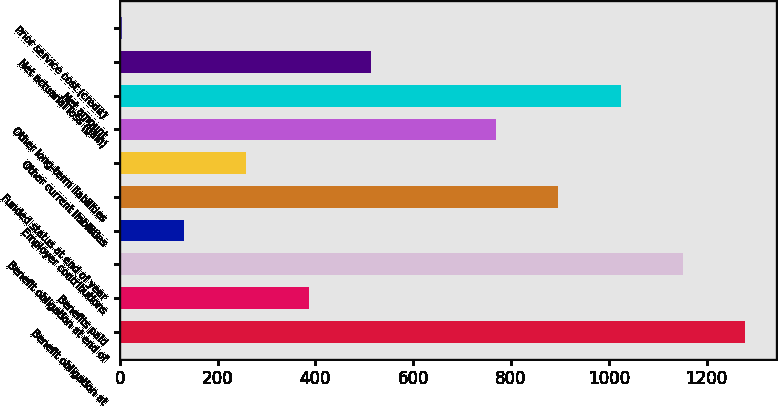<chart> <loc_0><loc_0><loc_500><loc_500><bar_chart><fcel>Benefit obligation at<fcel>Benefits paid<fcel>Benefit obligation at end of<fcel>Employer contributions<fcel>Funded status at end of year<fcel>Other current liabilities<fcel>Other long-term liabilities<fcel>Net amount<fcel>Net actuarial loss (gain)<fcel>Prior service cost (credit)<nl><fcel>1279<fcel>386.5<fcel>1151.5<fcel>131.5<fcel>896.5<fcel>259<fcel>769<fcel>1024<fcel>514<fcel>4<nl></chart> 